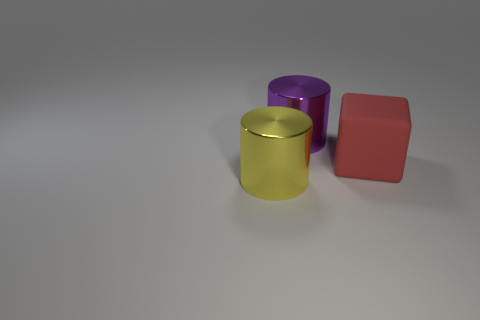Are there an equal number of big metallic things in front of the big purple cylinder and blocks?
Provide a succinct answer. Yes. How many purple cubes are made of the same material as the big yellow thing?
Make the answer very short. 0. What is the color of the big thing that is made of the same material as the purple cylinder?
Your answer should be very brief. Yellow. There is a red rubber cube; does it have the same size as the metal cylinder that is in front of the large block?
Offer a terse response. Yes. There is a large red thing; what shape is it?
Give a very brief answer. Cube. How many big metallic cylinders are the same color as the matte object?
Provide a short and direct response. 0. What is the color of the other thing that is the same shape as the yellow object?
Your response must be concise. Purple. There is a cylinder in front of the matte thing; what number of large yellow cylinders are in front of it?
Keep it short and to the point. 0. What number of cubes are either red rubber objects or big objects?
Keep it short and to the point. 1. Is there a big blue rubber block?
Offer a very short reply. No. 